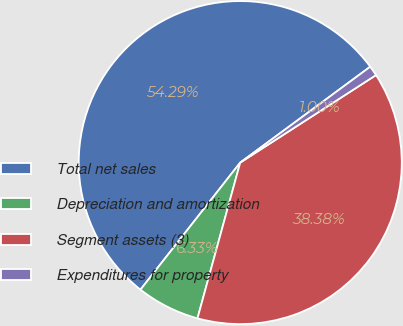Convert chart. <chart><loc_0><loc_0><loc_500><loc_500><pie_chart><fcel>Total net sales<fcel>Depreciation and amortization<fcel>Segment assets (3)<fcel>Expenditures for property<nl><fcel>54.3%<fcel>6.33%<fcel>38.38%<fcel>1.0%<nl></chart> 